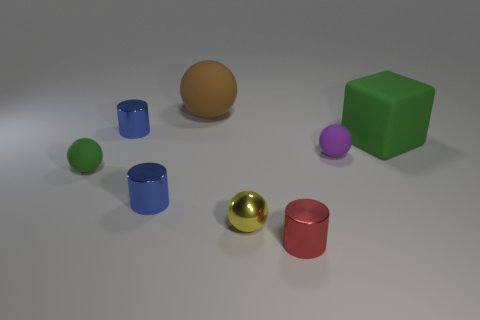Add 2 green matte balls. How many objects exist? 10 Subtract all cylinders. How many objects are left? 5 Add 4 green matte things. How many green matte things exist? 6 Subtract 0 red spheres. How many objects are left? 8 Subtract all tiny rubber cubes. Subtract all small matte balls. How many objects are left? 6 Add 3 tiny cylinders. How many tiny cylinders are left? 6 